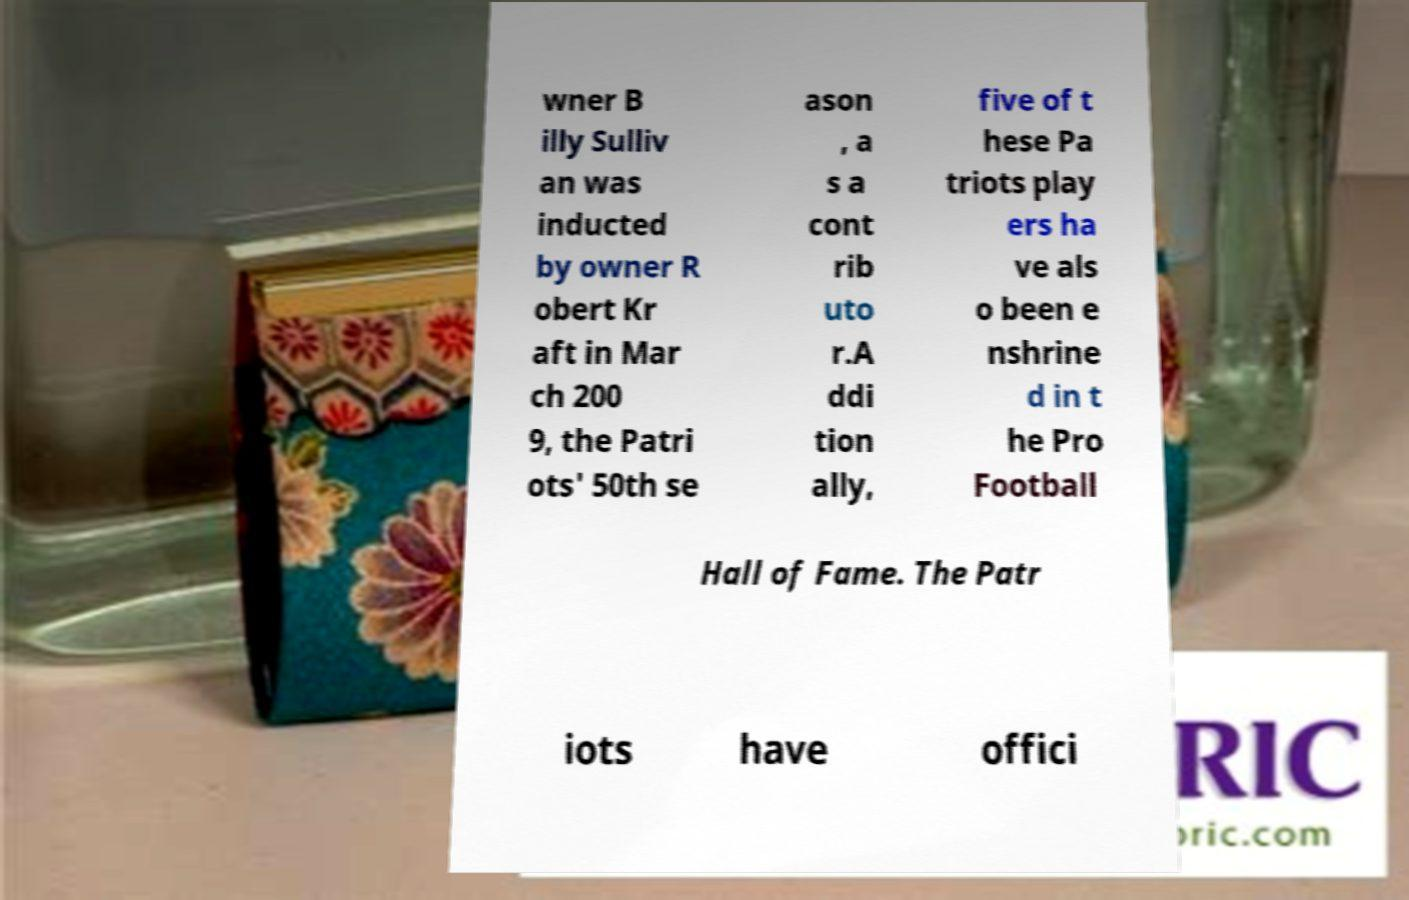Please read and relay the text visible in this image. What does it say? wner B illy Sulliv an was inducted by owner R obert Kr aft in Mar ch 200 9, the Patri ots' 50th se ason , a s a cont rib uto r.A ddi tion ally, five of t hese Pa triots play ers ha ve als o been e nshrine d in t he Pro Football Hall of Fame. The Patr iots have offici 